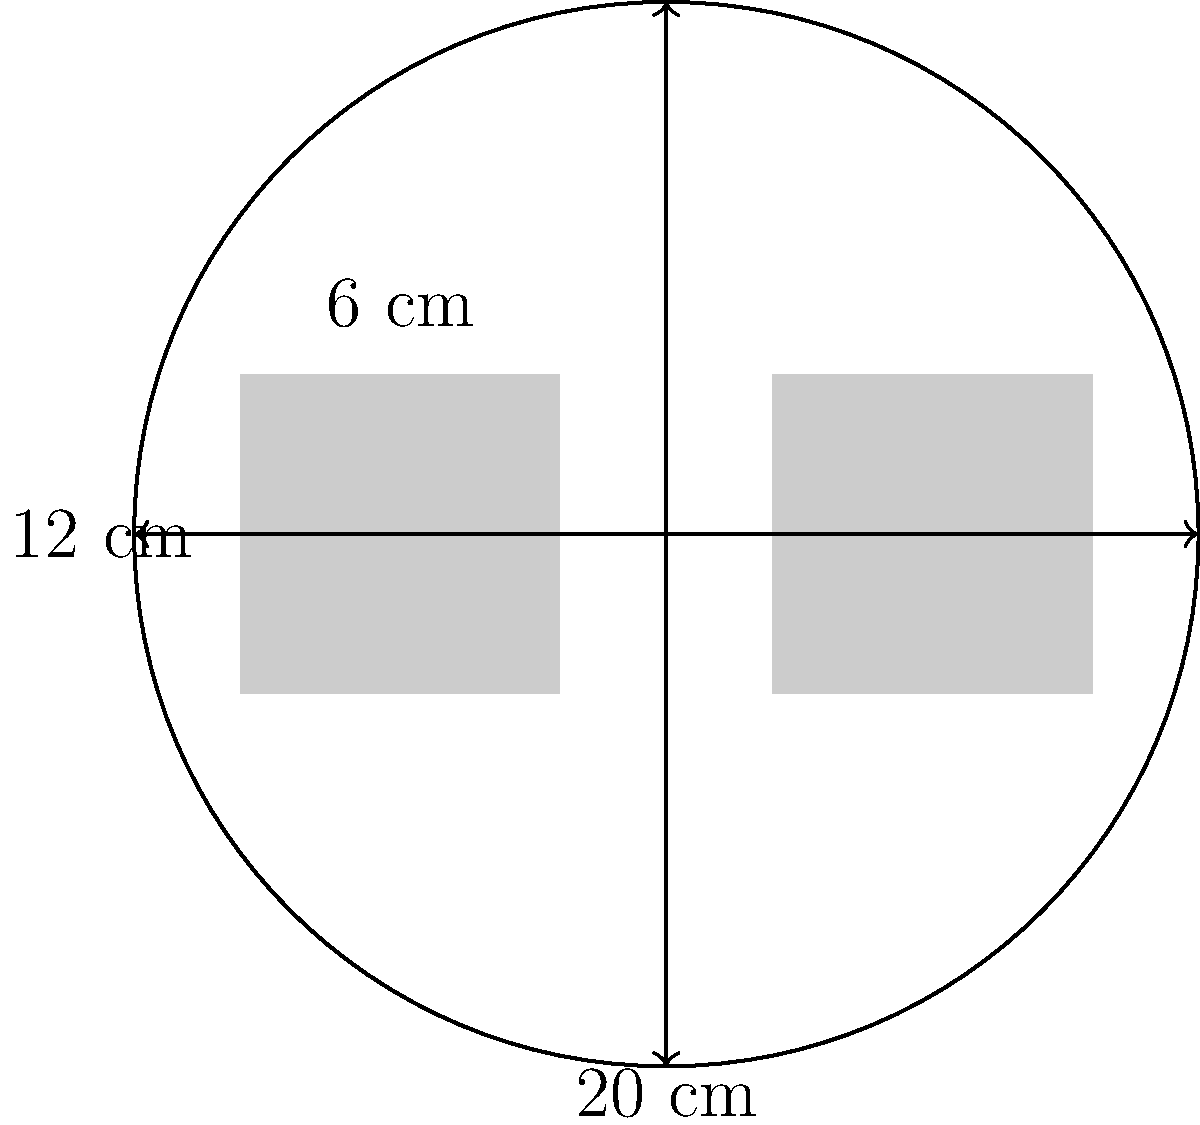As a textile manufacturer, you're considering a new cutting process for rectangular fabric pieces. The circular cutting area has a diameter of 20 cm. What is the maximum number of 12 cm × 6 cm rectangular pieces that can be cut from this area while minimizing waste? To solve this problem, we need to follow these steps:

1. Calculate the area of the circular cutting region:
   Area of circle = $\pi r^2 = \pi (10 \text{ cm})^2 = 100\pi \text{ cm}^2$

2. Calculate the area of each rectangular piece:
   Area of rectangle = $12 \text{ cm} \times 6 \text{ cm} = 72 \text{ cm}^2$

3. Determine the theoretical maximum number of pieces:
   Maximum pieces = $\frac{\text{Area of circle}}{\text{Area of rectangle}} = \frac{100\pi \text{ cm}^2}{72 \text{ cm}^2} \approx 4.36$

4. Consider the optimal arrangement:
   - The most efficient arrangement is to place the rectangles side by side along the diameter of the circle.
   - The diameter is 20 cm, which can fit exactly two 6 cm wide rectangles with an 8 cm gap between them.

5. Check if there's room for more pieces:
   - The remaining 8 cm gap is not wide enough to fit another 6 cm wide rectangle.
   - Rotating the rectangles wouldn't improve the fit due to the circular shape.

Therefore, the maximum number of 12 cm × 6 cm rectangular pieces that can be cut from this circular area while minimizing waste is 2.
Answer: 2 pieces 